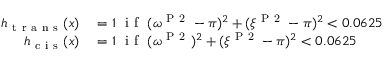<formula> <loc_0><loc_0><loc_500><loc_500>\begin{array} { r l } { h _ { t r a n s } ( x ) } & = 1 \ i f \ ( \omega ^ { P 2 } - \pi ) ^ { 2 } + ( \xi ^ { P 2 } - \pi ) ^ { 2 } < 0 . 0 6 2 5 } \\ { h _ { c i s } ( x ) } & = 1 \ i f \ ( \omega ^ { P 2 } ) ^ { 2 } + ( \xi ^ { P 2 } - \pi ) ^ { 2 } < 0 . 0 6 2 5 } \end{array}</formula> 